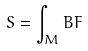Convert formula to latex. <formula><loc_0><loc_0><loc_500><loc_500>S = \int _ { M } B F</formula> 